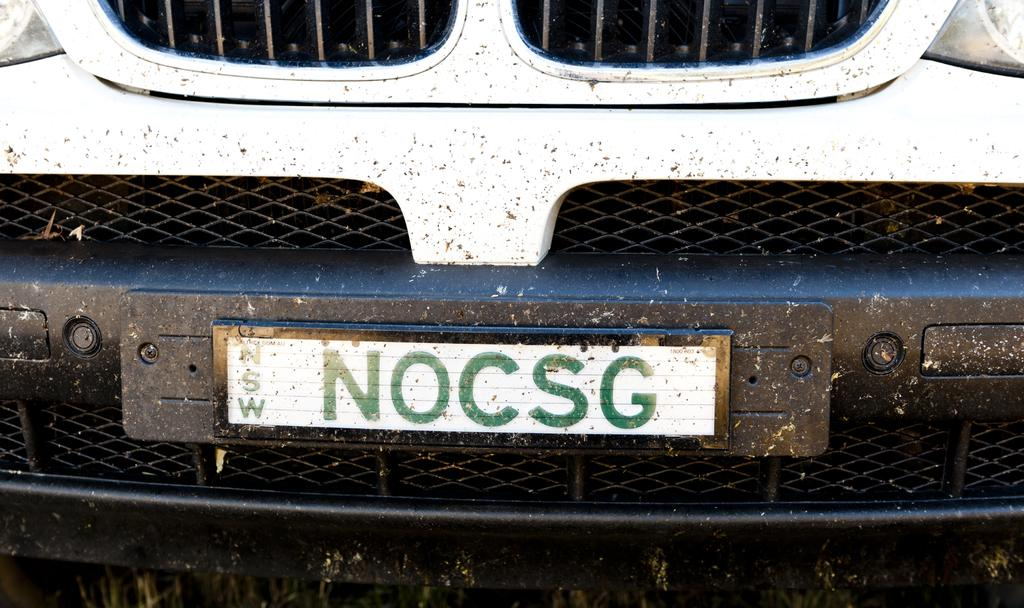<image>
Share a concise interpretation of the image provided. White and green license plate which says NOCSG on it. 